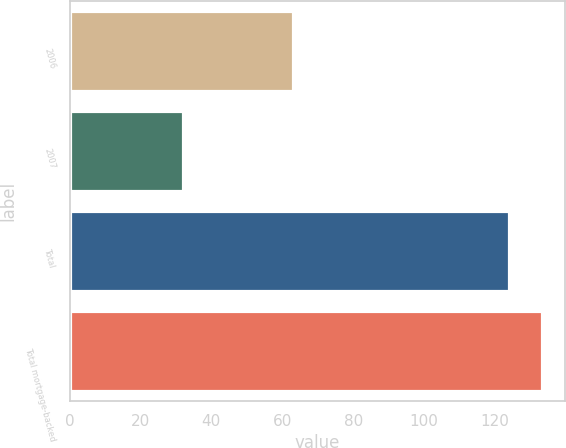<chart> <loc_0><loc_0><loc_500><loc_500><bar_chart><fcel>2006<fcel>2007<fcel>Total<fcel>Total mortgage-backed<nl><fcel>63<fcel>32<fcel>124<fcel>133.2<nl></chart> 